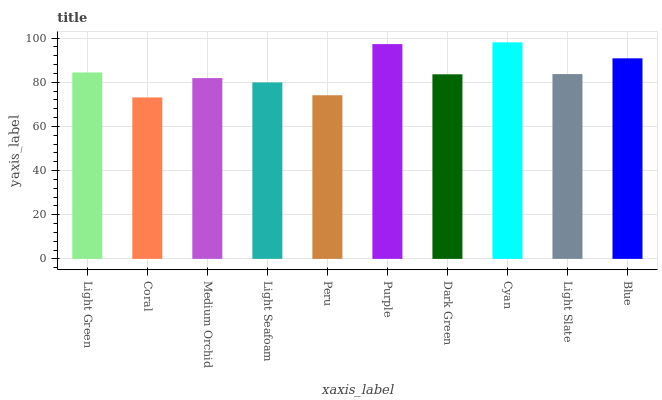Is Coral the minimum?
Answer yes or no. Yes. Is Cyan the maximum?
Answer yes or no. Yes. Is Medium Orchid the minimum?
Answer yes or no. No. Is Medium Orchid the maximum?
Answer yes or no. No. Is Medium Orchid greater than Coral?
Answer yes or no. Yes. Is Coral less than Medium Orchid?
Answer yes or no. Yes. Is Coral greater than Medium Orchid?
Answer yes or no. No. Is Medium Orchid less than Coral?
Answer yes or no. No. Is Light Slate the high median?
Answer yes or no. Yes. Is Dark Green the low median?
Answer yes or no. Yes. Is Coral the high median?
Answer yes or no. No. Is Medium Orchid the low median?
Answer yes or no. No. 